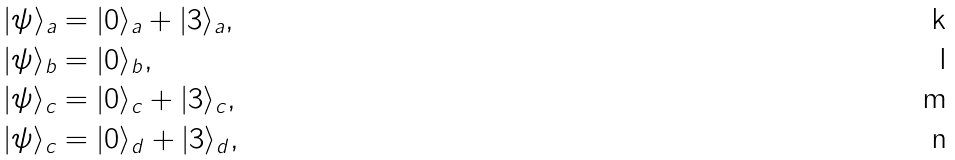Convert formula to latex. <formula><loc_0><loc_0><loc_500><loc_500>| \psi \rangle _ { a } & = | 0 \rangle _ { a } + | 3 \rangle _ { a } , \\ | \psi \rangle _ { b } & = | 0 \rangle _ { b } , \\ | \psi \rangle _ { c } & = | 0 \rangle _ { c } + | 3 \rangle _ { c } , \\ | \psi \rangle _ { c } & = | 0 \rangle _ { d } + | 3 \rangle _ { d } ,</formula> 